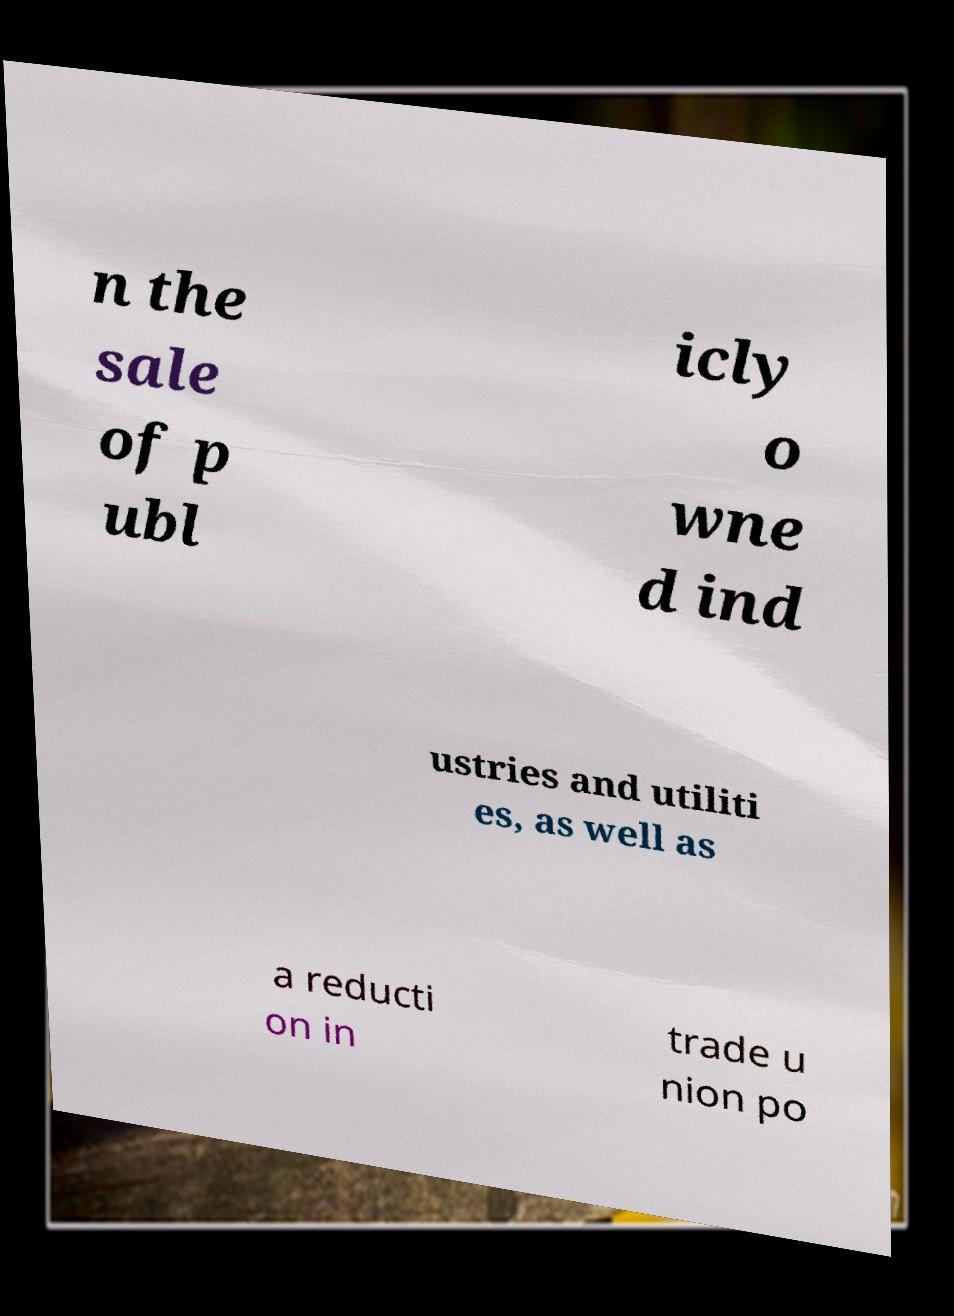For documentation purposes, I need the text within this image transcribed. Could you provide that? n the sale of p ubl icly o wne d ind ustries and utiliti es, as well as a reducti on in trade u nion po 